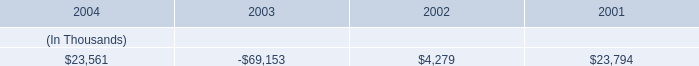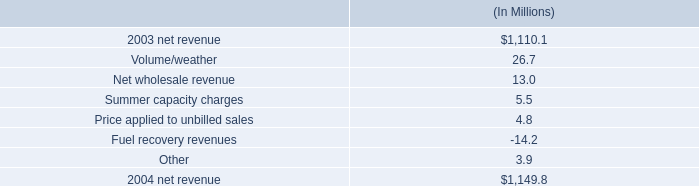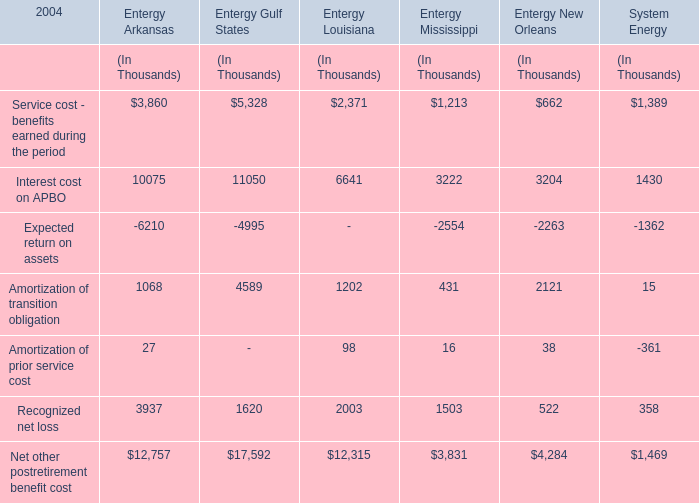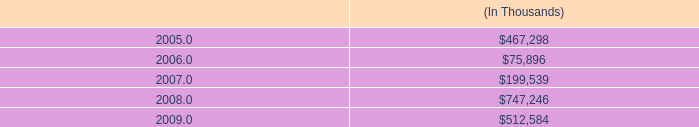what is the increase in construction expenditures as a percentage of the increase in net cash used in investing activities in 2003? 
Computations: (57.4 / 88.1)
Answer: 0.65153. 